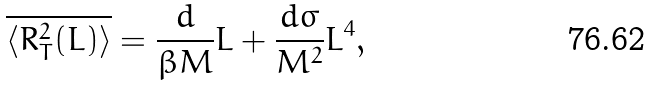<formula> <loc_0><loc_0><loc_500><loc_500>\overline { { \langle } { R } _ { T } ^ { 2 } ( L ) { \rangle } } = \frac { d } { \beta M } L + \frac { d \sigma } { M ^ { 2 } } L ^ { 4 } ,</formula> 